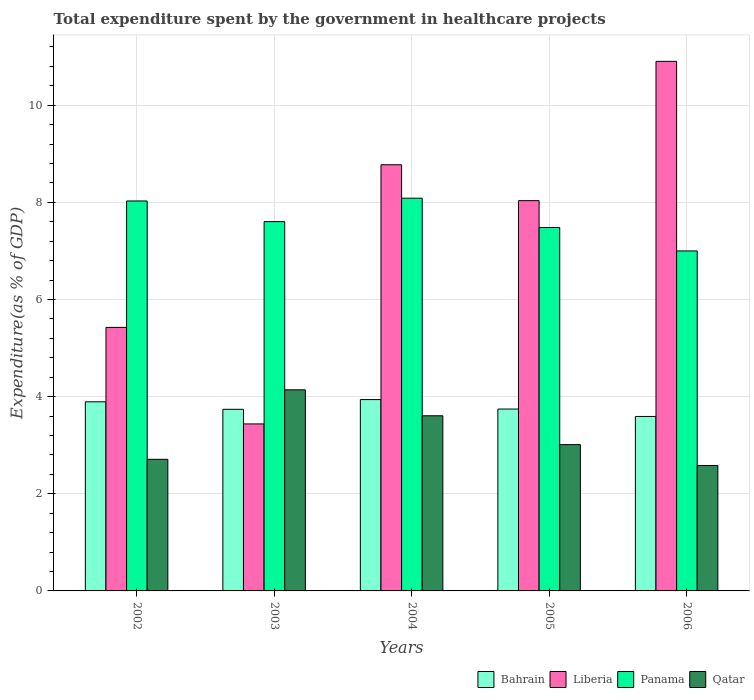How many different coloured bars are there?
Your answer should be very brief. 4. How many groups of bars are there?
Keep it short and to the point. 5. Are the number of bars per tick equal to the number of legend labels?
Make the answer very short. Yes. Are the number of bars on each tick of the X-axis equal?
Your response must be concise. Yes. In how many cases, is the number of bars for a given year not equal to the number of legend labels?
Make the answer very short. 0. What is the total expenditure spent by the government in healthcare projects in Panama in 2004?
Ensure brevity in your answer.  8.09. Across all years, what is the maximum total expenditure spent by the government in healthcare projects in Liberia?
Ensure brevity in your answer.  10.9. Across all years, what is the minimum total expenditure spent by the government in healthcare projects in Qatar?
Keep it short and to the point. 2.58. In which year was the total expenditure spent by the government in healthcare projects in Bahrain minimum?
Offer a terse response. 2006. What is the total total expenditure spent by the government in healthcare projects in Panama in the graph?
Give a very brief answer. 38.2. What is the difference between the total expenditure spent by the government in healthcare projects in Qatar in 2005 and that in 2006?
Offer a terse response. 0.43. What is the difference between the total expenditure spent by the government in healthcare projects in Qatar in 2002 and the total expenditure spent by the government in healthcare projects in Liberia in 2004?
Your answer should be compact. -6.06. What is the average total expenditure spent by the government in healthcare projects in Qatar per year?
Your answer should be compact. 3.21. In the year 2003, what is the difference between the total expenditure spent by the government in healthcare projects in Bahrain and total expenditure spent by the government in healthcare projects in Qatar?
Offer a terse response. -0.4. In how many years, is the total expenditure spent by the government in healthcare projects in Liberia greater than 1.2000000000000002 %?
Your response must be concise. 5. What is the ratio of the total expenditure spent by the government in healthcare projects in Panama in 2005 to that in 2006?
Your answer should be compact. 1.07. Is the total expenditure spent by the government in healthcare projects in Liberia in 2003 less than that in 2004?
Your response must be concise. Yes. Is the difference between the total expenditure spent by the government in healthcare projects in Bahrain in 2002 and 2003 greater than the difference between the total expenditure spent by the government in healthcare projects in Qatar in 2002 and 2003?
Your answer should be very brief. Yes. What is the difference between the highest and the second highest total expenditure spent by the government in healthcare projects in Qatar?
Your answer should be very brief. 0.53. What is the difference between the highest and the lowest total expenditure spent by the government in healthcare projects in Bahrain?
Provide a succinct answer. 0.35. In how many years, is the total expenditure spent by the government in healthcare projects in Panama greater than the average total expenditure spent by the government in healthcare projects in Panama taken over all years?
Offer a very short reply. 2. Is the sum of the total expenditure spent by the government in healthcare projects in Bahrain in 2003 and 2005 greater than the maximum total expenditure spent by the government in healthcare projects in Liberia across all years?
Your answer should be compact. No. What does the 3rd bar from the left in 2003 represents?
Provide a succinct answer. Panama. What does the 4th bar from the right in 2006 represents?
Ensure brevity in your answer.  Bahrain. Is it the case that in every year, the sum of the total expenditure spent by the government in healthcare projects in Liberia and total expenditure spent by the government in healthcare projects in Bahrain is greater than the total expenditure spent by the government in healthcare projects in Panama?
Keep it short and to the point. No. How many bars are there?
Keep it short and to the point. 20. How many years are there in the graph?
Provide a succinct answer. 5. What is the difference between two consecutive major ticks on the Y-axis?
Ensure brevity in your answer.  2. Does the graph contain grids?
Offer a very short reply. Yes. What is the title of the graph?
Offer a very short reply. Total expenditure spent by the government in healthcare projects. What is the label or title of the Y-axis?
Make the answer very short. Expenditure(as % of GDP). What is the Expenditure(as % of GDP) of Bahrain in 2002?
Your answer should be compact. 3.89. What is the Expenditure(as % of GDP) in Liberia in 2002?
Keep it short and to the point. 5.43. What is the Expenditure(as % of GDP) of Panama in 2002?
Your response must be concise. 8.03. What is the Expenditure(as % of GDP) in Qatar in 2002?
Ensure brevity in your answer.  2.71. What is the Expenditure(as % of GDP) of Bahrain in 2003?
Keep it short and to the point. 3.74. What is the Expenditure(as % of GDP) of Liberia in 2003?
Make the answer very short. 3.44. What is the Expenditure(as % of GDP) of Panama in 2003?
Your answer should be very brief. 7.6. What is the Expenditure(as % of GDP) in Qatar in 2003?
Offer a terse response. 4.14. What is the Expenditure(as % of GDP) of Bahrain in 2004?
Offer a terse response. 3.94. What is the Expenditure(as % of GDP) of Liberia in 2004?
Your answer should be very brief. 8.77. What is the Expenditure(as % of GDP) in Panama in 2004?
Give a very brief answer. 8.09. What is the Expenditure(as % of GDP) of Qatar in 2004?
Offer a very short reply. 3.61. What is the Expenditure(as % of GDP) in Bahrain in 2005?
Your response must be concise. 3.74. What is the Expenditure(as % of GDP) in Liberia in 2005?
Your response must be concise. 8.04. What is the Expenditure(as % of GDP) in Panama in 2005?
Offer a very short reply. 7.48. What is the Expenditure(as % of GDP) of Qatar in 2005?
Offer a very short reply. 3.01. What is the Expenditure(as % of GDP) in Bahrain in 2006?
Offer a terse response. 3.59. What is the Expenditure(as % of GDP) in Liberia in 2006?
Provide a succinct answer. 10.9. What is the Expenditure(as % of GDP) in Panama in 2006?
Keep it short and to the point. 7. What is the Expenditure(as % of GDP) of Qatar in 2006?
Make the answer very short. 2.58. Across all years, what is the maximum Expenditure(as % of GDP) of Bahrain?
Offer a very short reply. 3.94. Across all years, what is the maximum Expenditure(as % of GDP) in Liberia?
Offer a terse response. 10.9. Across all years, what is the maximum Expenditure(as % of GDP) in Panama?
Ensure brevity in your answer.  8.09. Across all years, what is the maximum Expenditure(as % of GDP) of Qatar?
Offer a very short reply. 4.14. Across all years, what is the minimum Expenditure(as % of GDP) of Bahrain?
Your answer should be compact. 3.59. Across all years, what is the minimum Expenditure(as % of GDP) of Liberia?
Provide a short and direct response. 3.44. Across all years, what is the minimum Expenditure(as % of GDP) of Panama?
Keep it short and to the point. 7. Across all years, what is the minimum Expenditure(as % of GDP) of Qatar?
Ensure brevity in your answer.  2.58. What is the total Expenditure(as % of GDP) of Bahrain in the graph?
Ensure brevity in your answer.  18.91. What is the total Expenditure(as % of GDP) of Liberia in the graph?
Keep it short and to the point. 36.58. What is the total Expenditure(as % of GDP) in Panama in the graph?
Give a very brief answer. 38.2. What is the total Expenditure(as % of GDP) of Qatar in the graph?
Provide a succinct answer. 16.05. What is the difference between the Expenditure(as % of GDP) of Bahrain in 2002 and that in 2003?
Offer a terse response. 0.15. What is the difference between the Expenditure(as % of GDP) of Liberia in 2002 and that in 2003?
Ensure brevity in your answer.  1.99. What is the difference between the Expenditure(as % of GDP) of Panama in 2002 and that in 2003?
Provide a succinct answer. 0.42. What is the difference between the Expenditure(as % of GDP) of Qatar in 2002 and that in 2003?
Ensure brevity in your answer.  -1.43. What is the difference between the Expenditure(as % of GDP) of Bahrain in 2002 and that in 2004?
Provide a short and direct response. -0.05. What is the difference between the Expenditure(as % of GDP) in Liberia in 2002 and that in 2004?
Your answer should be compact. -3.35. What is the difference between the Expenditure(as % of GDP) of Panama in 2002 and that in 2004?
Offer a very short reply. -0.06. What is the difference between the Expenditure(as % of GDP) of Qatar in 2002 and that in 2004?
Provide a succinct answer. -0.9. What is the difference between the Expenditure(as % of GDP) of Bahrain in 2002 and that in 2005?
Your answer should be very brief. 0.15. What is the difference between the Expenditure(as % of GDP) in Liberia in 2002 and that in 2005?
Your response must be concise. -2.61. What is the difference between the Expenditure(as % of GDP) of Panama in 2002 and that in 2005?
Ensure brevity in your answer.  0.55. What is the difference between the Expenditure(as % of GDP) of Qatar in 2002 and that in 2005?
Your answer should be compact. -0.3. What is the difference between the Expenditure(as % of GDP) in Bahrain in 2002 and that in 2006?
Your answer should be very brief. 0.3. What is the difference between the Expenditure(as % of GDP) of Liberia in 2002 and that in 2006?
Offer a terse response. -5.48. What is the difference between the Expenditure(as % of GDP) of Panama in 2002 and that in 2006?
Keep it short and to the point. 1.03. What is the difference between the Expenditure(as % of GDP) of Qatar in 2002 and that in 2006?
Make the answer very short. 0.13. What is the difference between the Expenditure(as % of GDP) of Liberia in 2003 and that in 2004?
Give a very brief answer. -5.34. What is the difference between the Expenditure(as % of GDP) of Panama in 2003 and that in 2004?
Provide a short and direct response. -0.48. What is the difference between the Expenditure(as % of GDP) in Qatar in 2003 and that in 2004?
Give a very brief answer. 0.53. What is the difference between the Expenditure(as % of GDP) of Bahrain in 2003 and that in 2005?
Your answer should be compact. -0. What is the difference between the Expenditure(as % of GDP) of Liberia in 2003 and that in 2005?
Give a very brief answer. -4.6. What is the difference between the Expenditure(as % of GDP) of Panama in 2003 and that in 2005?
Offer a very short reply. 0.12. What is the difference between the Expenditure(as % of GDP) of Qatar in 2003 and that in 2005?
Your response must be concise. 1.13. What is the difference between the Expenditure(as % of GDP) of Bahrain in 2003 and that in 2006?
Your response must be concise. 0.15. What is the difference between the Expenditure(as % of GDP) of Liberia in 2003 and that in 2006?
Your answer should be compact. -7.47. What is the difference between the Expenditure(as % of GDP) in Panama in 2003 and that in 2006?
Offer a very short reply. 0.6. What is the difference between the Expenditure(as % of GDP) of Qatar in 2003 and that in 2006?
Offer a terse response. 1.56. What is the difference between the Expenditure(as % of GDP) of Bahrain in 2004 and that in 2005?
Your answer should be very brief. 0.2. What is the difference between the Expenditure(as % of GDP) of Liberia in 2004 and that in 2005?
Offer a very short reply. 0.74. What is the difference between the Expenditure(as % of GDP) of Panama in 2004 and that in 2005?
Keep it short and to the point. 0.6. What is the difference between the Expenditure(as % of GDP) in Qatar in 2004 and that in 2005?
Give a very brief answer. 0.59. What is the difference between the Expenditure(as % of GDP) of Bahrain in 2004 and that in 2006?
Provide a succinct answer. 0.35. What is the difference between the Expenditure(as % of GDP) in Liberia in 2004 and that in 2006?
Offer a terse response. -2.13. What is the difference between the Expenditure(as % of GDP) in Panama in 2004 and that in 2006?
Your answer should be very brief. 1.09. What is the difference between the Expenditure(as % of GDP) of Qatar in 2004 and that in 2006?
Offer a terse response. 1.02. What is the difference between the Expenditure(as % of GDP) of Bahrain in 2005 and that in 2006?
Ensure brevity in your answer.  0.15. What is the difference between the Expenditure(as % of GDP) of Liberia in 2005 and that in 2006?
Offer a terse response. -2.87. What is the difference between the Expenditure(as % of GDP) of Panama in 2005 and that in 2006?
Offer a very short reply. 0.48. What is the difference between the Expenditure(as % of GDP) of Qatar in 2005 and that in 2006?
Provide a short and direct response. 0.43. What is the difference between the Expenditure(as % of GDP) of Bahrain in 2002 and the Expenditure(as % of GDP) of Liberia in 2003?
Your response must be concise. 0.46. What is the difference between the Expenditure(as % of GDP) of Bahrain in 2002 and the Expenditure(as % of GDP) of Panama in 2003?
Ensure brevity in your answer.  -3.71. What is the difference between the Expenditure(as % of GDP) of Bahrain in 2002 and the Expenditure(as % of GDP) of Qatar in 2003?
Make the answer very short. -0.25. What is the difference between the Expenditure(as % of GDP) in Liberia in 2002 and the Expenditure(as % of GDP) in Panama in 2003?
Your answer should be compact. -2.18. What is the difference between the Expenditure(as % of GDP) in Liberia in 2002 and the Expenditure(as % of GDP) in Qatar in 2003?
Keep it short and to the point. 1.29. What is the difference between the Expenditure(as % of GDP) in Panama in 2002 and the Expenditure(as % of GDP) in Qatar in 2003?
Your answer should be compact. 3.89. What is the difference between the Expenditure(as % of GDP) in Bahrain in 2002 and the Expenditure(as % of GDP) in Liberia in 2004?
Your answer should be compact. -4.88. What is the difference between the Expenditure(as % of GDP) of Bahrain in 2002 and the Expenditure(as % of GDP) of Panama in 2004?
Offer a very short reply. -4.19. What is the difference between the Expenditure(as % of GDP) in Bahrain in 2002 and the Expenditure(as % of GDP) in Qatar in 2004?
Your response must be concise. 0.29. What is the difference between the Expenditure(as % of GDP) of Liberia in 2002 and the Expenditure(as % of GDP) of Panama in 2004?
Keep it short and to the point. -2.66. What is the difference between the Expenditure(as % of GDP) of Liberia in 2002 and the Expenditure(as % of GDP) of Qatar in 2004?
Provide a succinct answer. 1.82. What is the difference between the Expenditure(as % of GDP) of Panama in 2002 and the Expenditure(as % of GDP) of Qatar in 2004?
Offer a terse response. 4.42. What is the difference between the Expenditure(as % of GDP) in Bahrain in 2002 and the Expenditure(as % of GDP) in Liberia in 2005?
Offer a terse response. -4.14. What is the difference between the Expenditure(as % of GDP) of Bahrain in 2002 and the Expenditure(as % of GDP) of Panama in 2005?
Give a very brief answer. -3.59. What is the difference between the Expenditure(as % of GDP) of Bahrain in 2002 and the Expenditure(as % of GDP) of Qatar in 2005?
Your answer should be compact. 0.88. What is the difference between the Expenditure(as % of GDP) in Liberia in 2002 and the Expenditure(as % of GDP) in Panama in 2005?
Make the answer very short. -2.06. What is the difference between the Expenditure(as % of GDP) in Liberia in 2002 and the Expenditure(as % of GDP) in Qatar in 2005?
Offer a very short reply. 2.41. What is the difference between the Expenditure(as % of GDP) in Panama in 2002 and the Expenditure(as % of GDP) in Qatar in 2005?
Give a very brief answer. 5.02. What is the difference between the Expenditure(as % of GDP) of Bahrain in 2002 and the Expenditure(as % of GDP) of Liberia in 2006?
Offer a very short reply. -7.01. What is the difference between the Expenditure(as % of GDP) in Bahrain in 2002 and the Expenditure(as % of GDP) in Panama in 2006?
Give a very brief answer. -3.11. What is the difference between the Expenditure(as % of GDP) of Bahrain in 2002 and the Expenditure(as % of GDP) of Qatar in 2006?
Make the answer very short. 1.31. What is the difference between the Expenditure(as % of GDP) of Liberia in 2002 and the Expenditure(as % of GDP) of Panama in 2006?
Ensure brevity in your answer.  -1.57. What is the difference between the Expenditure(as % of GDP) of Liberia in 2002 and the Expenditure(as % of GDP) of Qatar in 2006?
Your answer should be very brief. 2.84. What is the difference between the Expenditure(as % of GDP) in Panama in 2002 and the Expenditure(as % of GDP) in Qatar in 2006?
Your answer should be compact. 5.45. What is the difference between the Expenditure(as % of GDP) of Bahrain in 2003 and the Expenditure(as % of GDP) of Liberia in 2004?
Give a very brief answer. -5.04. What is the difference between the Expenditure(as % of GDP) in Bahrain in 2003 and the Expenditure(as % of GDP) in Panama in 2004?
Offer a terse response. -4.35. What is the difference between the Expenditure(as % of GDP) of Bahrain in 2003 and the Expenditure(as % of GDP) of Qatar in 2004?
Your response must be concise. 0.13. What is the difference between the Expenditure(as % of GDP) of Liberia in 2003 and the Expenditure(as % of GDP) of Panama in 2004?
Provide a short and direct response. -4.65. What is the difference between the Expenditure(as % of GDP) of Liberia in 2003 and the Expenditure(as % of GDP) of Qatar in 2004?
Give a very brief answer. -0.17. What is the difference between the Expenditure(as % of GDP) in Panama in 2003 and the Expenditure(as % of GDP) in Qatar in 2004?
Your response must be concise. 4. What is the difference between the Expenditure(as % of GDP) of Bahrain in 2003 and the Expenditure(as % of GDP) of Liberia in 2005?
Offer a very short reply. -4.3. What is the difference between the Expenditure(as % of GDP) in Bahrain in 2003 and the Expenditure(as % of GDP) in Panama in 2005?
Make the answer very short. -3.74. What is the difference between the Expenditure(as % of GDP) in Bahrain in 2003 and the Expenditure(as % of GDP) in Qatar in 2005?
Your response must be concise. 0.73. What is the difference between the Expenditure(as % of GDP) in Liberia in 2003 and the Expenditure(as % of GDP) in Panama in 2005?
Your answer should be compact. -4.05. What is the difference between the Expenditure(as % of GDP) of Liberia in 2003 and the Expenditure(as % of GDP) of Qatar in 2005?
Offer a terse response. 0.43. What is the difference between the Expenditure(as % of GDP) of Panama in 2003 and the Expenditure(as % of GDP) of Qatar in 2005?
Your response must be concise. 4.59. What is the difference between the Expenditure(as % of GDP) of Bahrain in 2003 and the Expenditure(as % of GDP) of Liberia in 2006?
Offer a very short reply. -7.16. What is the difference between the Expenditure(as % of GDP) in Bahrain in 2003 and the Expenditure(as % of GDP) in Panama in 2006?
Offer a very short reply. -3.26. What is the difference between the Expenditure(as % of GDP) of Bahrain in 2003 and the Expenditure(as % of GDP) of Qatar in 2006?
Your answer should be very brief. 1.16. What is the difference between the Expenditure(as % of GDP) of Liberia in 2003 and the Expenditure(as % of GDP) of Panama in 2006?
Make the answer very short. -3.56. What is the difference between the Expenditure(as % of GDP) in Liberia in 2003 and the Expenditure(as % of GDP) in Qatar in 2006?
Your answer should be compact. 0.86. What is the difference between the Expenditure(as % of GDP) in Panama in 2003 and the Expenditure(as % of GDP) in Qatar in 2006?
Offer a terse response. 5.02. What is the difference between the Expenditure(as % of GDP) in Bahrain in 2004 and the Expenditure(as % of GDP) in Liberia in 2005?
Provide a short and direct response. -4.1. What is the difference between the Expenditure(as % of GDP) of Bahrain in 2004 and the Expenditure(as % of GDP) of Panama in 2005?
Your response must be concise. -3.54. What is the difference between the Expenditure(as % of GDP) of Bahrain in 2004 and the Expenditure(as % of GDP) of Qatar in 2005?
Make the answer very short. 0.93. What is the difference between the Expenditure(as % of GDP) of Liberia in 2004 and the Expenditure(as % of GDP) of Panama in 2005?
Provide a succinct answer. 1.29. What is the difference between the Expenditure(as % of GDP) of Liberia in 2004 and the Expenditure(as % of GDP) of Qatar in 2005?
Your response must be concise. 5.76. What is the difference between the Expenditure(as % of GDP) of Panama in 2004 and the Expenditure(as % of GDP) of Qatar in 2005?
Your answer should be very brief. 5.07. What is the difference between the Expenditure(as % of GDP) in Bahrain in 2004 and the Expenditure(as % of GDP) in Liberia in 2006?
Offer a terse response. -6.96. What is the difference between the Expenditure(as % of GDP) in Bahrain in 2004 and the Expenditure(as % of GDP) in Panama in 2006?
Give a very brief answer. -3.06. What is the difference between the Expenditure(as % of GDP) in Bahrain in 2004 and the Expenditure(as % of GDP) in Qatar in 2006?
Your response must be concise. 1.36. What is the difference between the Expenditure(as % of GDP) in Liberia in 2004 and the Expenditure(as % of GDP) in Panama in 2006?
Offer a very short reply. 1.77. What is the difference between the Expenditure(as % of GDP) in Liberia in 2004 and the Expenditure(as % of GDP) in Qatar in 2006?
Your response must be concise. 6.19. What is the difference between the Expenditure(as % of GDP) in Panama in 2004 and the Expenditure(as % of GDP) in Qatar in 2006?
Keep it short and to the point. 5.5. What is the difference between the Expenditure(as % of GDP) in Bahrain in 2005 and the Expenditure(as % of GDP) in Liberia in 2006?
Provide a succinct answer. -7.16. What is the difference between the Expenditure(as % of GDP) of Bahrain in 2005 and the Expenditure(as % of GDP) of Panama in 2006?
Offer a very short reply. -3.26. What is the difference between the Expenditure(as % of GDP) in Bahrain in 2005 and the Expenditure(as % of GDP) in Qatar in 2006?
Provide a succinct answer. 1.16. What is the difference between the Expenditure(as % of GDP) of Liberia in 2005 and the Expenditure(as % of GDP) of Panama in 2006?
Your response must be concise. 1.04. What is the difference between the Expenditure(as % of GDP) in Liberia in 2005 and the Expenditure(as % of GDP) in Qatar in 2006?
Keep it short and to the point. 5.45. What is the difference between the Expenditure(as % of GDP) in Panama in 2005 and the Expenditure(as % of GDP) in Qatar in 2006?
Provide a succinct answer. 4.9. What is the average Expenditure(as % of GDP) in Bahrain per year?
Your answer should be compact. 3.78. What is the average Expenditure(as % of GDP) in Liberia per year?
Your response must be concise. 7.32. What is the average Expenditure(as % of GDP) in Panama per year?
Your answer should be very brief. 7.64. What is the average Expenditure(as % of GDP) in Qatar per year?
Your answer should be compact. 3.21. In the year 2002, what is the difference between the Expenditure(as % of GDP) of Bahrain and Expenditure(as % of GDP) of Liberia?
Make the answer very short. -1.53. In the year 2002, what is the difference between the Expenditure(as % of GDP) in Bahrain and Expenditure(as % of GDP) in Panama?
Provide a succinct answer. -4.14. In the year 2002, what is the difference between the Expenditure(as % of GDP) in Bahrain and Expenditure(as % of GDP) in Qatar?
Your response must be concise. 1.18. In the year 2002, what is the difference between the Expenditure(as % of GDP) of Liberia and Expenditure(as % of GDP) of Panama?
Make the answer very short. -2.6. In the year 2002, what is the difference between the Expenditure(as % of GDP) of Liberia and Expenditure(as % of GDP) of Qatar?
Your answer should be compact. 2.72. In the year 2002, what is the difference between the Expenditure(as % of GDP) of Panama and Expenditure(as % of GDP) of Qatar?
Keep it short and to the point. 5.32. In the year 2003, what is the difference between the Expenditure(as % of GDP) in Bahrain and Expenditure(as % of GDP) in Liberia?
Give a very brief answer. 0.3. In the year 2003, what is the difference between the Expenditure(as % of GDP) of Bahrain and Expenditure(as % of GDP) of Panama?
Your answer should be compact. -3.86. In the year 2003, what is the difference between the Expenditure(as % of GDP) of Bahrain and Expenditure(as % of GDP) of Qatar?
Make the answer very short. -0.4. In the year 2003, what is the difference between the Expenditure(as % of GDP) in Liberia and Expenditure(as % of GDP) in Panama?
Provide a succinct answer. -4.17. In the year 2003, what is the difference between the Expenditure(as % of GDP) of Liberia and Expenditure(as % of GDP) of Qatar?
Make the answer very short. -0.7. In the year 2003, what is the difference between the Expenditure(as % of GDP) in Panama and Expenditure(as % of GDP) in Qatar?
Your answer should be very brief. 3.46. In the year 2004, what is the difference between the Expenditure(as % of GDP) of Bahrain and Expenditure(as % of GDP) of Liberia?
Provide a succinct answer. -4.84. In the year 2004, what is the difference between the Expenditure(as % of GDP) in Bahrain and Expenditure(as % of GDP) in Panama?
Give a very brief answer. -4.15. In the year 2004, what is the difference between the Expenditure(as % of GDP) in Bahrain and Expenditure(as % of GDP) in Qatar?
Provide a short and direct response. 0.33. In the year 2004, what is the difference between the Expenditure(as % of GDP) in Liberia and Expenditure(as % of GDP) in Panama?
Give a very brief answer. 0.69. In the year 2004, what is the difference between the Expenditure(as % of GDP) in Liberia and Expenditure(as % of GDP) in Qatar?
Your response must be concise. 5.17. In the year 2004, what is the difference between the Expenditure(as % of GDP) in Panama and Expenditure(as % of GDP) in Qatar?
Make the answer very short. 4.48. In the year 2005, what is the difference between the Expenditure(as % of GDP) in Bahrain and Expenditure(as % of GDP) in Liberia?
Offer a very short reply. -4.29. In the year 2005, what is the difference between the Expenditure(as % of GDP) of Bahrain and Expenditure(as % of GDP) of Panama?
Offer a very short reply. -3.74. In the year 2005, what is the difference between the Expenditure(as % of GDP) in Bahrain and Expenditure(as % of GDP) in Qatar?
Give a very brief answer. 0.73. In the year 2005, what is the difference between the Expenditure(as % of GDP) of Liberia and Expenditure(as % of GDP) of Panama?
Offer a very short reply. 0.55. In the year 2005, what is the difference between the Expenditure(as % of GDP) of Liberia and Expenditure(as % of GDP) of Qatar?
Give a very brief answer. 5.02. In the year 2005, what is the difference between the Expenditure(as % of GDP) of Panama and Expenditure(as % of GDP) of Qatar?
Keep it short and to the point. 4.47. In the year 2006, what is the difference between the Expenditure(as % of GDP) of Bahrain and Expenditure(as % of GDP) of Liberia?
Offer a terse response. -7.31. In the year 2006, what is the difference between the Expenditure(as % of GDP) in Bahrain and Expenditure(as % of GDP) in Panama?
Offer a very short reply. -3.41. In the year 2006, what is the difference between the Expenditure(as % of GDP) in Bahrain and Expenditure(as % of GDP) in Qatar?
Your answer should be compact. 1.01. In the year 2006, what is the difference between the Expenditure(as % of GDP) in Liberia and Expenditure(as % of GDP) in Panama?
Offer a terse response. 3.9. In the year 2006, what is the difference between the Expenditure(as % of GDP) of Liberia and Expenditure(as % of GDP) of Qatar?
Your response must be concise. 8.32. In the year 2006, what is the difference between the Expenditure(as % of GDP) in Panama and Expenditure(as % of GDP) in Qatar?
Provide a succinct answer. 4.42. What is the ratio of the Expenditure(as % of GDP) of Bahrain in 2002 to that in 2003?
Your answer should be very brief. 1.04. What is the ratio of the Expenditure(as % of GDP) of Liberia in 2002 to that in 2003?
Offer a terse response. 1.58. What is the ratio of the Expenditure(as % of GDP) in Panama in 2002 to that in 2003?
Provide a short and direct response. 1.06. What is the ratio of the Expenditure(as % of GDP) in Qatar in 2002 to that in 2003?
Ensure brevity in your answer.  0.65. What is the ratio of the Expenditure(as % of GDP) in Bahrain in 2002 to that in 2004?
Ensure brevity in your answer.  0.99. What is the ratio of the Expenditure(as % of GDP) in Liberia in 2002 to that in 2004?
Keep it short and to the point. 0.62. What is the ratio of the Expenditure(as % of GDP) of Qatar in 2002 to that in 2004?
Provide a succinct answer. 0.75. What is the ratio of the Expenditure(as % of GDP) in Bahrain in 2002 to that in 2005?
Provide a succinct answer. 1.04. What is the ratio of the Expenditure(as % of GDP) of Liberia in 2002 to that in 2005?
Provide a succinct answer. 0.68. What is the ratio of the Expenditure(as % of GDP) of Panama in 2002 to that in 2005?
Your answer should be very brief. 1.07. What is the ratio of the Expenditure(as % of GDP) in Qatar in 2002 to that in 2005?
Provide a short and direct response. 0.9. What is the ratio of the Expenditure(as % of GDP) in Bahrain in 2002 to that in 2006?
Your answer should be very brief. 1.08. What is the ratio of the Expenditure(as % of GDP) of Liberia in 2002 to that in 2006?
Your answer should be compact. 0.5. What is the ratio of the Expenditure(as % of GDP) in Panama in 2002 to that in 2006?
Offer a terse response. 1.15. What is the ratio of the Expenditure(as % of GDP) in Qatar in 2002 to that in 2006?
Give a very brief answer. 1.05. What is the ratio of the Expenditure(as % of GDP) of Bahrain in 2003 to that in 2004?
Offer a terse response. 0.95. What is the ratio of the Expenditure(as % of GDP) in Liberia in 2003 to that in 2004?
Your answer should be compact. 0.39. What is the ratio of the Expenditure(as % of GDP) of Panama in 2003 to that in 2004?
Your response must be concise. 0.94. What is the ratio of the Expenditure(as % of GDP) of Qatar in 2003 to that in 2004?
Your answer should be very brief. 1.15. What is the ratio of the Expenditure(as % of GDP) of Bahrain in 2003 to that in 2005?
Your answer should be compact. 1. What is the ratio of the Expenditure(as % of GDP) of Liberia in 2003 to that in 2005?
Give a very brief answer. 0.43. What is the ratio of the Expenditure(as % of GDP) of Panama in 2003 to that in 2005?
Provide a short and direct response. 1.02. What is the ratio of the Expenditure(as % of GDP) in Qatar in 2003 to that in 2005?
Offer a terse response. 1.37. What is the ratio of the Expenditure(as % of GDP) of Bahrain in 2003 to that in 2006?
Make the answer very short. 1.04. What is the ratio of the Expenditure(as % of GDP) in Liberia in 2003 to that in 2006?
Keep it short and to the point. 0.32. What is the ratio of the Expenditure(as % of GDP) in Panama in 2003 to that in 2006?
Your answer should be very brief. 1.09. What is the ratio of the Expenditure(as % of GDP) of Qatar in 2003 to that in 2006?
Your response must be concise. 1.6. What is the ratio of the Expenditure(as % of GDP) in Bahrain in 2004 to that in 2005?
Keep it short and to the point. 1.05. What is the ratio of the Expenditure(as % of GDP) of Liberia in 2004 to that in 2005?
Offer a terse response. 1.09. What is the ratio of the Expenditure(as % of GDP) of Panama in 2004 to that in 2005?
Your answer should be compact. 1.08. What is the ratio of the Expenditure(as % of GDP) in Qatar in 2004 to that in 2005?
Your answer should be compact. 1.2. What is the ratio of the Expenditure(as % of GDP) in Bahrain in 2004 to that in 2006?
Your answer should be very brief. 1.1. What is the ratio of the Expenditure(as % of GDP) in Liberia in 2004 to that in 2006?
Give a very brief answer. 0.8. What is the ratio of the Expenditure(as % of GDP) in Panama in 2004 to that in 2006?
Your response must be concise. 1.16. What is the ratio of the Expenditure(as % of GDP) in Qatar in 2004 to that in 2006?
Ensure brevity in your answer.  1.4. What is the ratio of the Expenditure(as % of GDP) of Bahrain in 2005 to that in 2006?
Ensure brevity in your answer.  1.04. What is the ratio of the Expenditure(as % of GDP) of Liberia in 2005 to that in 2006?
Your answer should be very brief. 0.74. What is the ratio of the Expenditure(as % of GDP) in Panama in 2005 to that in 2006?
Offer a terse response. 1.07. What is the ratio of the Expenditure(as % of GDP) of Qatar in 2005 to that in 2006?
Keep it short and to the point. 1.17. What is the difference between the highest and the second highest Expenditure(as % of GDP) in Bahrain?
Keep it short and to the point. 0.05. What is the difference between the highest and the second highest Expenditure(as % of GDP) in Liberia?
Ensure brevity in your answer.  2.13. What is the difference between the highest and the second highest Expenditure(as % of GDP) of Panama?
Offer a very short reply. 0.06. What is the difference between the highest and the second highest Expenditure(as % of GDP) of Qatar?
Your answer should be very brief. 0.53. What is the difference between the highest and the lowest Expenditure(as % of GDP) of Bahrain?
Your response must be concise. 0.35. What is the difference between the highest and the lowest Expenditure(as % of GDP) of Liberia?
Offer a terse response. 7.47. What is the difference between the highest and the lowest Expenditure(as % of GDP) of Panama?
Your response must be concise. 1.09. What is the difference between the highest and the lowest Expenditure(as % of GDP) of Qatar?
Provide a succinct answer. 1.56. 